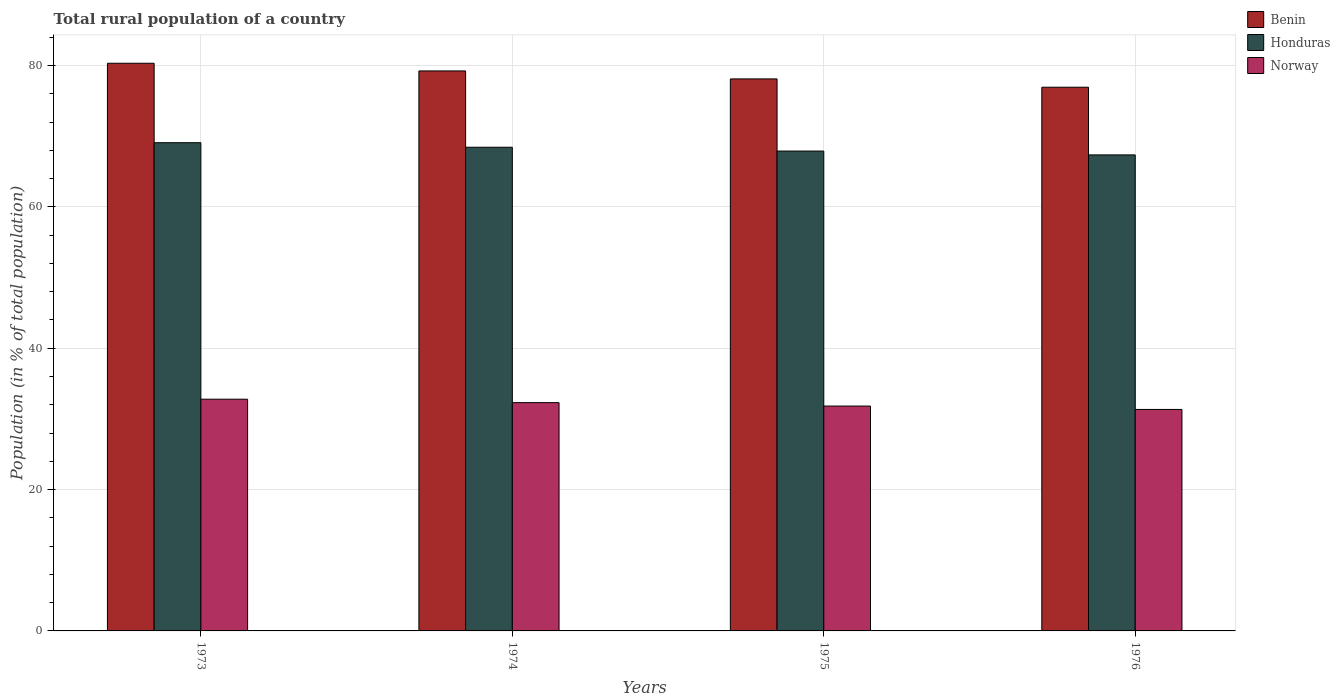How many groups of bars are there?
Give a very brief answer. 4. Are the number of bars per tick equal to the number of legend labels?
Offer a terse response. Yes. How many bars are there on the 2nd tick from the left?
Provide a succinct answer. 3. What is the label of the 2nd group of bars from the left?
Your answer should be very brief. 1974. What is the rural population in Honduras in 1974?
Ensure brevity in your answer.  68.43. Across all years, what is the maximum rural population in Honduras?
Provide a short and direct response. 69.07. Across all years, what is the minimum rural population in Benin?
Offer a terse response. 76.92. In which year was the rural population in Honduras maximum?
Offer a terse response. 1973. In which year was the rural population in Honduras minimum?
Offer a terse response. 1976. What is the total rural population in Honduras in the graph?
Provide a succinct answer. 272.74. What is the difference between the rural population in Norway in 1974 and that in 1976?
Your answer should be compact. 0.96. What is the difference between the rural population in Benin in 1976 and the rural population in Norway in 1974?
Provide a succinct answer. 44.62. What is the average rural population in Honduras per year?
Offer a very short reply. 68.18. In the year 1974, what is the difference between the rural population in Benin and rural population in Norway?
Make the answer very short. 46.93. In how many years, is the rural population in Norway greater than 52 %?
Make the answer very short. 0. What is the ratio of the rural population in Honduras in 1973 to that in 1976?
Keep it short and to the point. 1.03. Is the rural population in Honduras in 1974 less than that in 1975?
Give a very brief answer. No. Is the difference between the rural population in Benin in 1974 and 1976 greater than the difference between the rural population in Norway in 1974 and 1976?
Make the answer very short. Yes. What is the difference between the highest and the second highest rural population in Norway?
Your answer should be very brief. 0.49. What is the difference between the highest and the lowest rural population in Norway?
Ensure brevity in your answer.  1.45. In how many years, is the rural population in Honduras greater than the average rural population in Honduras taken over all years?
Provide a short and direct response. 2. What does the 1st bar from the left in 1974 represents?
Give a very brief answer. Benin. What does the 3rd bar from the right in 1975 represents?
Keep it short and to the point. Benin. How many bars are there?
Your response must be concise. 12. What is the difference between two consecutive major ticks on the Y-axis?
Make the answer very short. 20. Are the values on the major ticks of Y-axis written in scientific E-notation?
Give a very brief answer. No. Does the graph contain grids?
Give a very brief answer. Yes. How are the legend labels stacked?
Offer a very short reply. Vertical. What is the title of the graph?
Provide a succinct answer. Total rural population of a country. What is the label or title of the Y-axis?
Offer a terse response. Population (in % of total population). What is the Population (in % of total population) in Benin in 1973?
Make the answer very short. 80.31. What is the Population (in % of total population) in Honduras in 1973?
Make the answer very short. 69.07. What is the Population (in % of total population) in Norway in 1973?
Provide a short and direct response. 32.78. What is the Population (in % of total population) in Benin in 1974?
Ensure brevity in your answer.  79.22. What is the Population (in % of total population) of Honduras in 1974?
Your answer should be compact. 68.43. What is the Population (in % of total population) of Norway in 1974?
Ensure brevity in your answer.  32.3. What is the Population (in % of total population) in Benin in 1975?
Offer a very short reply. 78.1. What is the Population (in % of total population) of Honduras in 1975?
Give a very brief answer. 67.89. What is the Population (in % of total population) of Norway in 1975?
Offer a very short reply. 31.81. What is the Population (in % of total population) of Benin in 1976?
Give a very brief answer. 76.92. What is the Population (in % of total population) in Honduras in 1976?
Ensure brevity in your answer.  67.35. What is the Population (in % of total population) of Norway in 1976?
Offer a terse response. 31.33. Across all years, what is the maximum Population (in % of total population) in Benin?
Make the answer very short. 80.31. Across all years, what is the maximum Population (in % of total population) of Honduras?
Make the answer very short. 69.07. Across all years, what is the maximum Population (in % of total population) in Norway?
Your answer should be very brief. 32.78. Across all years, what is the minimum Population (in % of total population) of Benin?
Provide a short and direct response. 76.92. Across all years, what is the minimum Population (in % of total population) of Honduras?
Offer a very short reply. 67.35. Across all years, what is the minimum Population (in % of total population) in Norway?
Keep it short and to the point. 31.33. What is the total Population (in % of total population) of Benin in the graph?
Your answer should be compact. 314.55. What is the total Population (in % of total population) of Honduras in the graph?
Keep it short and to the point. 272.74. What is the total Population (in % of total population) of Norway in the graph?
Provide a short and direct response. 128.23. What is the difference between the Population (in % of total population) of Benin in 1973 and that in 1974?
Your response must be concise. 1.09. What is the difference between the Population (in % of total population) of Honduras in 1973 and that in 1974?
Give a very brief answer. 0.64. What is the difference between the Population (in % of total population) in Norway in 1973 and that in 1974?
Give a very brief answer. 0.49. What is the difference between the Population (in % of total population) of Benin in 1973 and that in 1975?
Make the answer very short. 2.21. What is the difference between the Population (in % of total population) of Honduras in 1973 and that in 1975?
Ensure brevity in your answer.  1.18. What is the difference between the Population (in % of total population) of Norway in 1973 and that in 1975?
Give a very brief answer. 0.97. What is the difference between the Population (in % of total population) in Benin in 1973 and that in 1976?
Your answer should be compact. 3.39. What is the difference between the Population (in % of total population) of Honduras in 1973 and that in 1976?
Provide a short and direct response. 1.72. What is the difference between the Population (in % of total population) in Norway in 1973 and that in 1976?
Make the answer very short. 1.45. What is the difference between the Population (in % of total population) in Benin in 1974 and that in 1975?
Give a very brief answer. 1.13. What is the difference between the Population (in % of total population) in Honduras in 1974 and that in 1975?
Offer a very short reply. 0.54. What is the difference between the Population (in % of total population) in Norway in 1974 and that in 1975?
Offer a very short reply. 0.48. What is the difference between the Population (in % of total population) of Benin in 1974 and that in 1976?
Your answer should be compact. 2.3. What is the difference between the Population (in % of total population) in Honduras in 1974 and that in 1976?
Your answer should be compact. 1.08. What is the difference between the Population (in % of total population) of Benin in 1975 and that in 1976?
Ensure brevity in your answer.  1.18. What is the difference between the Population (in % of total population) in Honduras in 1975 and that in 1976?
Provide a succinct answer. 0.54. What is the difference between the Population (in % of total population) in Norway in 1975 and that in 1976?
Ensure brevity in your answer.  0.48. What is the difference between the Population (in % of total population) of Benin in 1973 and the Population (in % of total population) of Honduras in 1974?
Your answer should be very brief. 11.88. What is the difference between the Population (in % of total population) in Benin in 1973 and the Population (in % of total population) in Norway in 1974?
Keep it short and to the point. 48.01. What is the difference between the Population (in % of total population) of Honduras in 1973 and the Population (in % of total population) of Norway in 1974?
Keep it short and to the point. 36.77. What is the difference between the Population (in % of total population) of Benin in 1973 and the Population (in % of total population) of Honduras in 1975?
Offer a terse response. 12.42. What is the difference between the Population (in % of total population) of Benin in 1973 and the Population (in % of total population) of Norway in 1975?
Offer a very short reply. 48.5. What is the difference between the Population (in % of total population) in Honduras in 1973 and the Population (in % of total population) in Norway in 1975?
Offer a terse response. 37.26. What is the difference between the Population (in % of total population) in Benin in 1973 and the Population (in % of total population) in Honduras in 1976?
Offer a very short reply. 12.96. What is the difference between the Population (in % of total population) in Benin in 1973 and the Population (in % of total population) in Norway in 1976?
Offer a very short reply. 48.98. What is the difference between the Population (in % of total population) of Honduras in 1973 and the Population (in % of total population) of Norway in 1976?
Keep it short and to the point. 37.74. What is the difference between the Population (in % of total population) of Benin in 1974 and the Population (in % of total population) of Honduras in 1975?
Offer a very short reply. 11.34. What is the difference between the Population (in % of total population) of Benin in 1974 and the Population (in % of total population) of Norway in 1975?
Your response must be concise. 47.41. What is the difference between the Population (in % of total population) of Honduras in 1974 and the Population (in % of total population) of Norway in 1975?
Your answer should be very brief. 36.62. What is the difference between the Population (in % of total population) of Benin in 1974 and the Population (in % of total population) of Honduras in 1976?
Provide a short and direct response. 11.88. What is the difference between the Population (in % of total population) of Benin in 1974 and the Population (in % of total population) of Norway in 1976?
Give a very brief answer. 47.89. What is the difference between the Population (in % of total population) of Honduras in 1974 and the Population (in % of total population) of Norway in 1976?
Your response must be concise. 37.1. What is the difference between the Population (in % of total population) of Benin in 1975 and the Population (in % of total population) of Honduras in 1976?
Keep it short and to the point. 10.75. What is the difference between the Population (in % of total population) of Benin in 1975 and the Population (in % of total population) of Norway in 1976?
Your answer should be compact. 46.76. What is the difference between the Population (in % of total population) of Honduras in 1975 and the Population (in % of total population) of Norway in 1976?
Offer a terse response. 36.56. What is the average Population (in % of total population) in Benin per year?
Ensure brevity in your answer.  78.64. What is the average Population (in % of total population) in Honduras per year?
Give a very brief answer. 68.18. What is the average Population (in % of total population) in Norway per year?
Ensure brevity in your answer.  32.06. In the year 1973, what is the difference between the Population (in % of total population) of Benin and Population (in % of total population) of Honduras?
Offer a very short reply. 11.24. In the year 1973, what is the difference between the Population (in % of total population) of Benin and Population (in % of total population) of Norway?
Offer a very short reply. 47.53. In the year 1973, what is the difference between the Population (in % of total population) of Honduras and Population (in % of total population) of Norway?
Keep it short and to the point. 36.29. In the year 1974, what is the difference between the Population (in % of total population) of Benin and Population (in % of total population) of Honduras?
Make the answer very short. 10.8. In the year 1974, what is the difference between the Population (in % of total population) of Benin and Population (in % of total population) of Norway?
Your answer should be compact. 46.93. In the year 1974, what is the difference between the Population (in % of total population) in Honduras and Population (in % of total population) in Norway?
Provide a short and direct response. 36.13. In the year 1975, what is the difference between the Population (in % of total population) of Benin and Population (in % of total population) of Honduras?
Make the answer very short. 10.21. In the year 1975, what is the difference between the Population (in % of total population) of Benin and Population (in % of total population) of Norway?
Your response must be concise. 46.28. In the year 1975, what is the difference between the Population (in % of total population) in Honduras and Population (in % of total population) in Norway?
Offer a very short reply. 36.08. In the year 1976, what is the difference between the Population (in % of total population) of Benin and Population (in % of total population) of Honduras?
Keep it short and to the point. 9.57. In the year 1976, what is the difference between the Population (in % of total population) of Benin and Population (in % of total population) of Norway?
Offer a very short reply. 45.59. In the year 1976, what is the difference between the Population (in % of total population) in Honduras and Population (in % of total population) in Norway?
Provide a succinct answer. 36.01. What is the ratio of the Population (in % of total population) in Benin in 1973 to that in 1974?
Your response must be concise. 1.01. What is the ratio of the Population (in % of total population) in Honduras in 1973 to that in 1974?
Provide a short and direct response. 1.01. What is the ratio of the Population (in % of total population) of Norway in 1973 to that in 1974?
Keep it short and to the point. 1.02. What is the ratio of the Population (in % of total population) of Benin in 1973 to that in 1975?
Your answer should be compact. 1.03. What is the ratio of the Population (in % of total population) of Honduras in 1973 to that in 1975?
Keep it short and to the point. 1.02. What is the ratio of the Population (in % of total population) in Norway in 1973 to that in 1975?
Keep it short and to the point. 1.03. What is the ratio of the Population (in % of total population) in Benin in 1973 to that in 1976?
Your answer should be very brief. 1.04. What is the ratio of the Population (in % of total population) in Honduras in 1973 to that in 1976?
Make the answer very short. 1.03. What is the ratio of the Population (in % of total population) in Norway in 1973 to that in 1976?
Your answer should be very brief. 1.05. What is the ratio of the Population (in % of total population) in Benin in 1974 to that in 1975?
Your response must be concise. 1.01. What is the ratio of the Population (in % of total population) in Honduras in 1974 to that in 1975?
Provide a succinct answer. 1.01. What is the ratio of the Population (in % of total population) in Norway in 1974 to that in 1975?
Offer a terse response. 1.02. What is the ratio of the Population (in % of total population) in Benin in 1974 to that in 1976?
Give a very brief answer. 1.03. What is the ratio of the Population (in % of total population) of Honduras in 1974 to that in 1976?
Offer a terse response. 1.02. What is the ratio of the Population (in % of total population) of Norway in 1974 to that in 1976?
Make the answer very short. 1.03. What is the ratio of the Population (in % of total population) of Benin in 1975 to that in 1976?
Provide a succinct answer. 1.02. What is the ratio of the Population (in % of total population) of Honduras in 1975 to that in 1976?
Provide a succinct answer. 1.01. What is the ratio of the Population (in % of total population) in Norway in 1975 to that in 1976?
Your response must be concise. 1.02. What is the difference between the highest and the second highest Population (in % of total population) of Benin?
Ensure brevity in your answer.  1.09. What is the difference between the highest and the second highest Population (in % of total population) in Honduras?
Your answer should be very brief. 0.64. What is the difference between the highest and the second highest Population (in % of total population) in Norway?
Provide a short and direct response. 0.49. What is the difference between the highest and the lowest Population (in % of total population) in Benin?
Offer a terse response. 3.39. What is the difference between the highest and the lowest Population (in % of total population) in Honduras?
Offer a terse response. 1.72. What is the difference between the highest and the lowest Population (in % of total population) in Norway?
Ensure brevity in your answer.  1.45. 